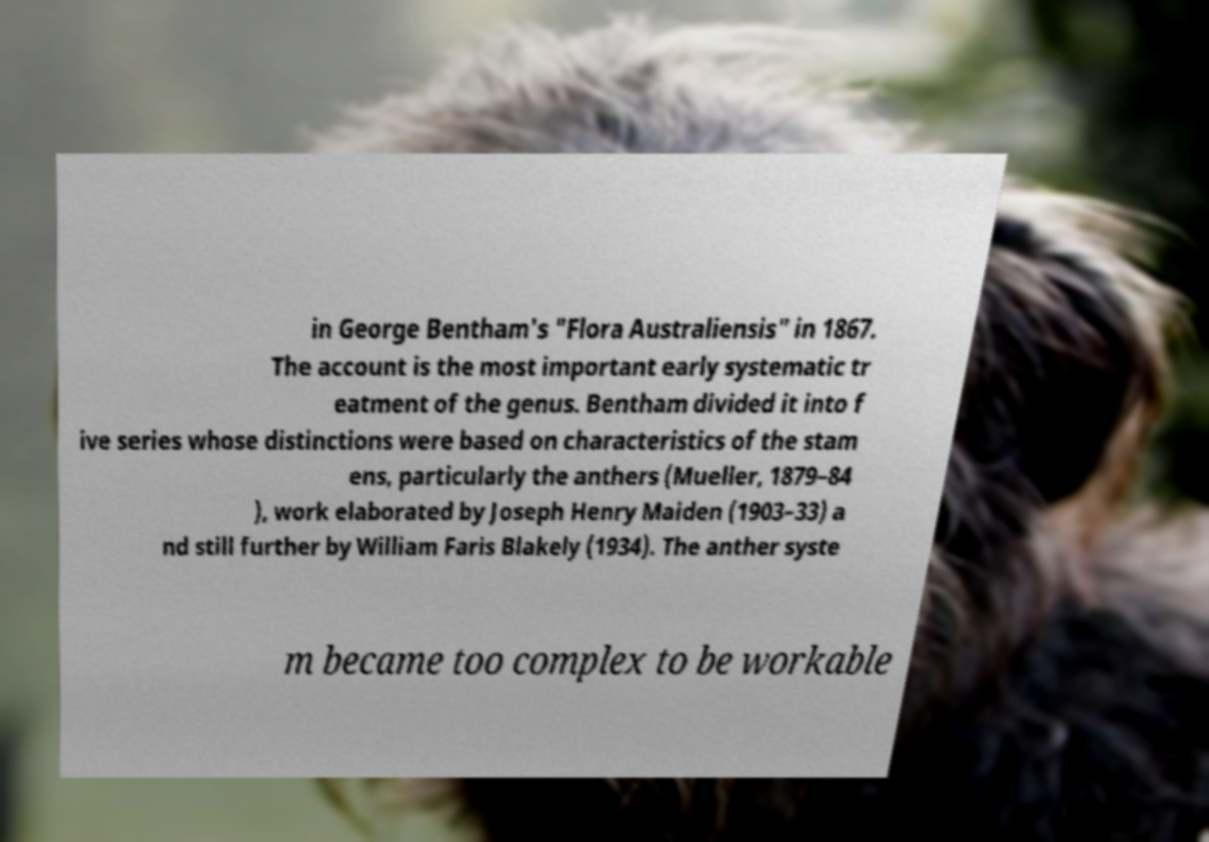Please read and relay the text visible in this image. What does it say? in George Bentham's "Flora Australiensis" in 1867. The account is the most important early systematic tr eatment of the genus. Bentham divided it into f ive series whose distinctions were based on characteristics of the stam ens, particularly the anthers (Mueller, 1879–84 ), work elaborated by Joseph Henry Maiden (1903–33) a nd still further by William Faris Blakely (1934). The anther syste m became too complex to be workable 